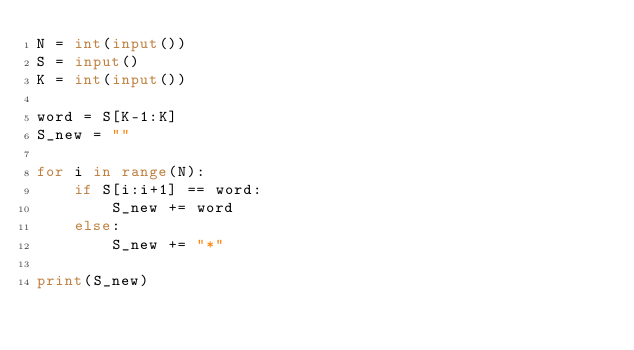<code> <loc_0><loc_0><loc_500><loc_500><_Python_>N = int(input())
S = input()
K = int(input())

word = S[K-1:K]
S_new = ""

for i in range(N):
    if S[i:i+1] == word:
        S_new += word
    else:
        S_new += "*"
        
print(S_new)</code> 